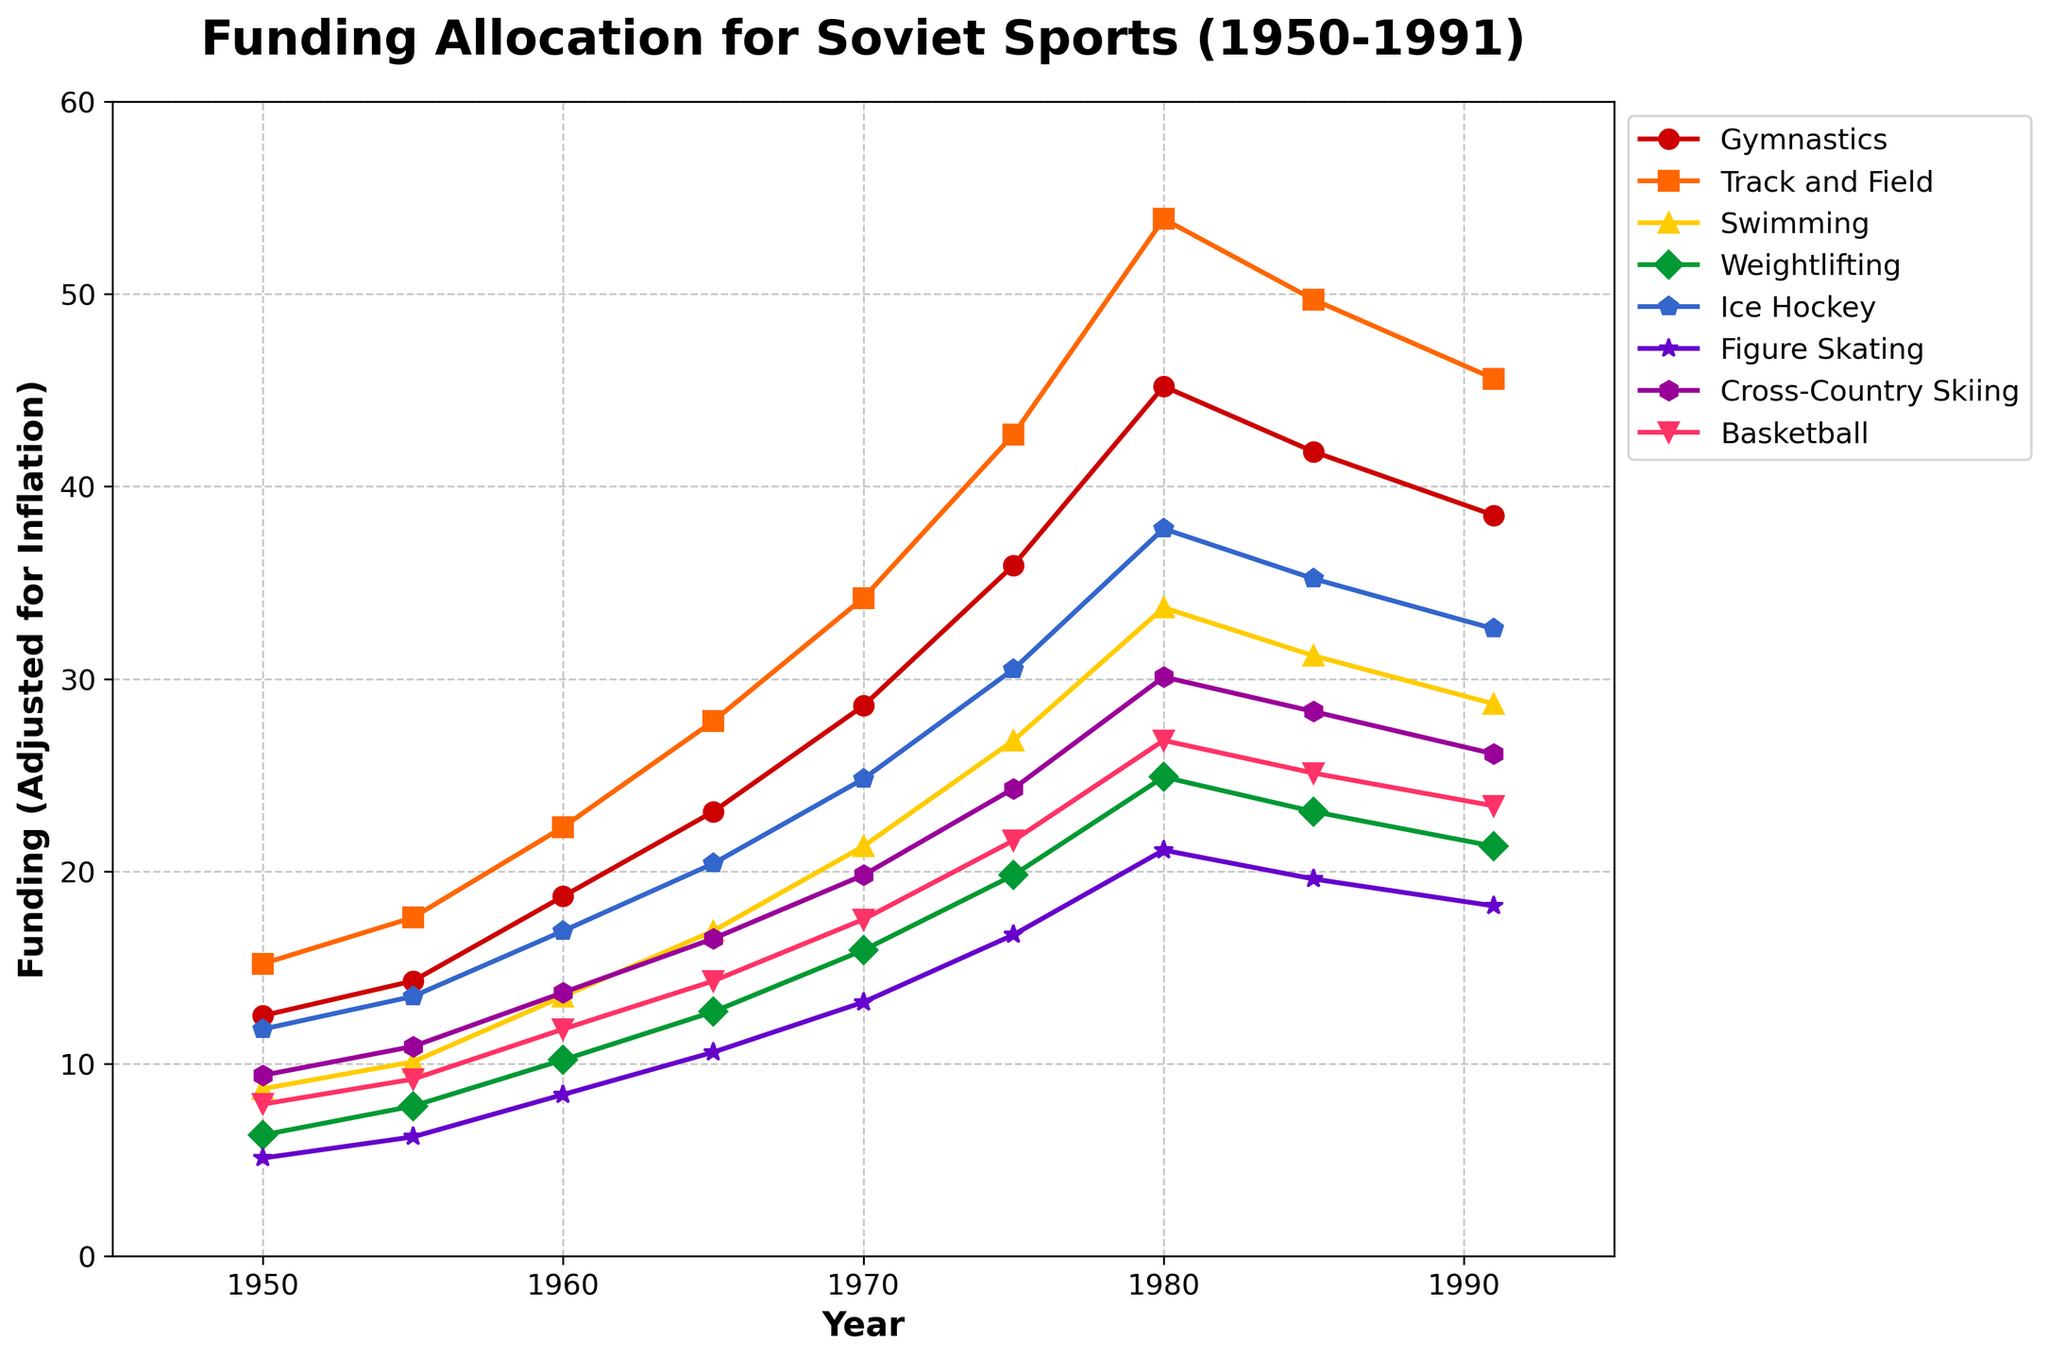What sport received the highest funding in 1980? In the year 1980, the plot shows different funding levels for each sport. The highest peak among all sports is for 'Track and Field.'
Answer: Track and Field Between 1960 and 1970, which sport had the greatest increase in funding? To find the greatest increase in funding between 1960 and 1970, we need to subtract the 1960 values from the 1970 values for each sport and compare the differences. 'Track and Field' had the highest increase, going from 22.3 to 34.2.
Answer: Track and Field Which sport experienced a funding decline between 1980 and 1991? By comparing the figures for 1980 and 1991, 'Gymnastics' funding decreased from 45.2 to 38.5.
Answer: Gymnastics In which decade did Figure Skating see the largest funding growth? By comparing funding values decade by decade, the largest growth for Figure Skating occurred between 1970 (13.2) and 1980 (21.1).
Answer: 1970-1980 What was the average funding for Ice Hockey across all recorded years? To find the average, sum the Ice Hockey values for each year and divide by the number of years. (11.8+13.5+16.9+20.4+24.8+30.5+37.8+35.2+32.6) / 9 = 24.27
Answer: 24.27 Which two sports had nearly equal funding levels in 1950? In 1950, 'Track and Field' and 'Ice Hockey' had funding levels of 15.2 and 11.8 respectively. The closest other pair is 'Gymnastics' and 'Cross-Country Skiing' both with values near 12.5 and 11.8.
Answer: Track and Field and Ice Hockey Was Basketball's funding higher or lower than Cross-Country Skiing's in 1985? In 1985, the funding for Basketball was 25.1, while for Cross-Country Skiing it was 28.3. Thus, it was lower.
Answer: Lower Which sport had the smallest funding change between 1985 and 1991? By comparing differences for each sport between 1985 and 1991, the smallest change is for Figure Skating, going from 19.6 to 18.2, a difference of 1.4.
Answer: Figure Skating During which five-year period did Swimming see the largest percentage increase in funding? To calculate percentage increases for each five-year period, the period from 1955 to 1960 shows the highest percentage increase, from 10.1 to 13.5, which is approximately a 33.66% increase.
Answer: 1955-1960 